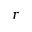Convert formula to latex. <formula><loc_0><loc_0><loc_500><loc_500>r</formula> 